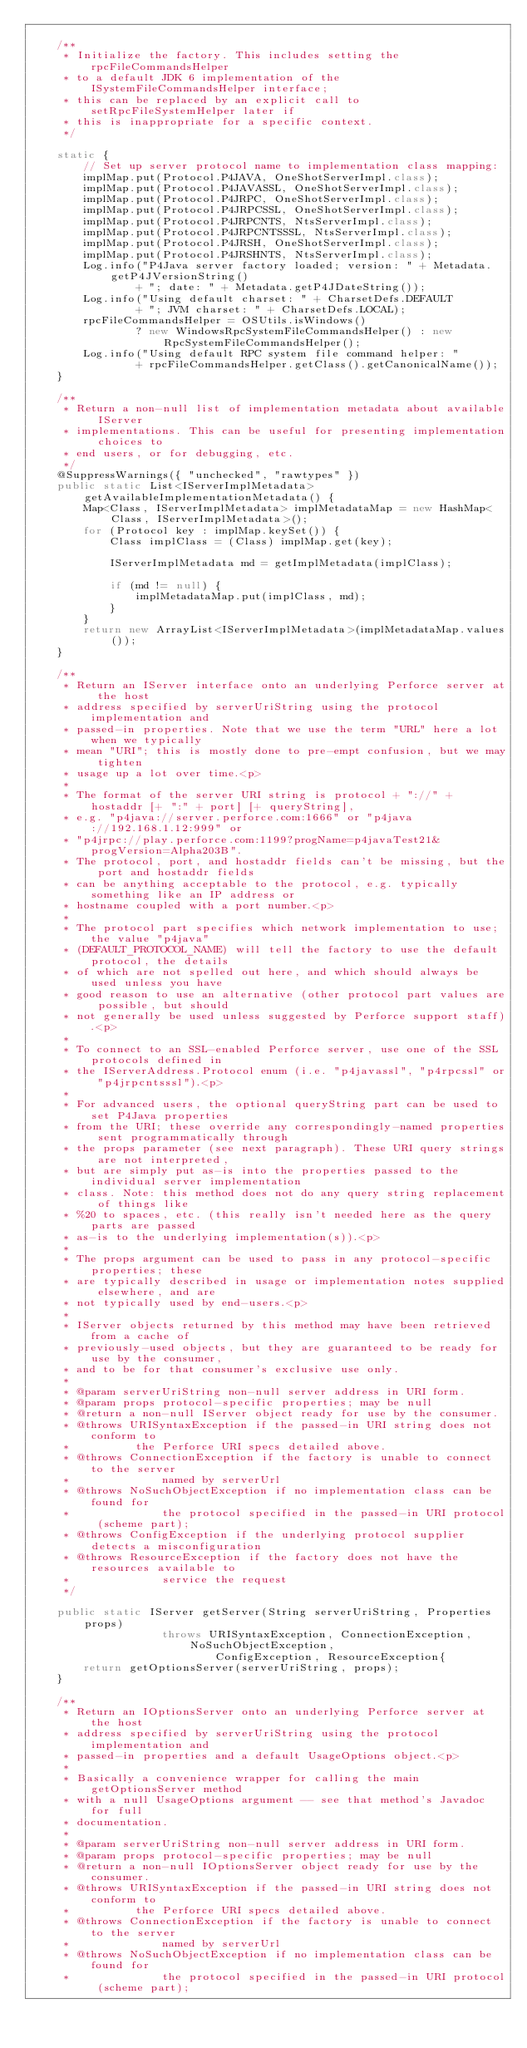<code> <loc_0><loc_0><loc_500><loc_500><_Java_>	
	/**
	 * Initialize the factory. This includes setting the rpcFileCommandsHelper
	 * to a default JDK 6 implementation of the ISystemFileCommandsHelper interface;
	 * this can be replaced by an explicit call to setRpcFileSystemHelper later if
	 * this is inappropriate for a specific context.
	 */
	
	static {
		// Set up server protocol name to implementation class mapping:
		implMap.put(Protocol.P4JAVA, OneShotServerImpl.class);
		implMap.put(Protocol.P4JAVASSL, OneShotServerImpl.class);
		implMap.put(Protocol.P4JRPC, OneShotServerImpl.class);
		implMap.put(Protocol.P4JRPCSSL, OneShotServerImpl.class);
		implMap.put(Protocol.P4JRPCNTS, NtsServerImpl.class);
		implMap.put(Protocol.P4JRPCNTSSSL, NtsServerImpl.class);
		implMap.put(Protocol.P4JRSH, OneShotServerImpl.class);
		implMap.put(Protocol.P4JRSHNTS, NtsServerImpl.class);
		Log.info("P4Java server factory loaded; version: " + Metadata.getP4JVersionString()
				+ "; date: " + Metadata.getP4JDateString());
		Log.info("Using default charset: " + CharsetDefs.DEFAULT
				+ "; JVM charset: " + CharsetDefs.LOCAL);
		rpcFileCommandsHelper = OSUtils.isWindows() 
		        ? new WindowsRpcSystemFileCommandsHelper() : new RpcSystemFileCommandsHelper();
		Log.info("Using default RPC system file command helper: "
				+ rpcFileCommandsHelper.getClass().getCanonicalName());
	}
	
	/**
	 * Return a non-null list of implementation metadata about available IServer
	 * implementations. This can be useful for presenting implementation choices to
	 * end users, or for debugging, etc.
	 */
	@SuppressWarnings({ "unchecked", "rawtypes" })
	public static List<IServerImplMetadata> getAvailableImplementationMetadata() {
		Map<Class, IServerImplMetadata> implMetadataMap = new HashMap<Class, IServerImplMetadata>();
		for (Protocol key : implMap.keySet()) {
			Class implClass = (Class) implMap.get(key);
			
			IServerImplMetadata md = getImplMetadata(implClass);
			
			if (md != null) {
				implMetadataMap.put(implClass, md);
			}
		}
		return new ArrayList<IServerImplMetadata>(implMetadataMap.values());
	}
	
	/**
	 * Return an IServer interface onto an underlying Perforce server at the host
	 * address specified by serverUriString using the protocol implementation and
	 * passed-in properties. Note that we use the term "URL" here a lot when we typically
	 * mean "URI"; this is mostly done to pre-empt confusion, but we may tighten
	 * usage up a lot over time.<p>
	 * 
	 * The format of the server URI string is protocol + "://" + hostaddr [+ ":" + port] [+ queryString],
	 * e.g. "p4java://server.perforce.com:1666" or "p4java://192.168.1.12:999" or
	 * "p4jrpc://play.perforce.com:1199?progName=p4javaTest21&progVersion=Alpha203B".
	 * The protocol, port, and hostaddr fields can't be missing, but the port and hostaddr fields
	 * can be anything acceptable to the protocol, e.g. typically something like an IP address or
	 * hostname coupled with a port number.<p>
	 * 
	 * The protocol part specifies which network implementation to use; the value "p4java"
	 * (DEFAULT_PROTOCOL_NAME) will tell the factory to use the default protocol, the details
	 * of which are not spelled out here, and which should always be used unless you have
	 * good reason to use an alternative (other protocol part values are possible, but should
	 * not generally be used unless suggested by Perforce support staff).<p>
	 * 
	 * To connect to an SSL-enabled Perforce server, use one of the SSL protocols defined in
	 * the IServerAddress.Protocol enum (i.e. "p4javassl", "p4rpcssl" or "p4jrpcntsssl").<p>
	 * 
	 * For advanced users, the optional queryString part can be used to set P4Java properties
	 * from the URI; these override any correspondingly-named properties sent programmatically through
	 * the props parameter (see next paragraph). These URI query strings are not interpreted,
	 * but are simply put as-is into the properties passed to the individual server implementation
	 * class. Note: this method does not do any query string replacement of things like
	 * %20 to spaces, etc. (this really isn't needed here as the query parts are passed
	 * as-is to the underlying implementation(s)).<p>
	 * 
	 * The props argument can be used to pass in any protocol-specific properties; these
	 * are typically described in usage or implementation notes supplied elsewhere, and are
	 * not typically used by end-users.<p>
	 * 
	 * IServer objects returned by this method may have been retrieved from a cache of
	 * previously-used objects, but they are guaranteed to be ready for use by the consumer,
	 * and to be for that consumer's exclusive use only.
	 * 
	 * @param serverUriString non-null server address in URI form.
	 * @param props protocol-specific properties; may be null
	 * @return a non-null IServer object ready for use by the consumer.
	 * @throws URISyntaxException if the passed-in URI string does not conform to
	 * 			the Perforce URI specs detailed above.
	 * @throws ConnectionException if the factory is unable to connect to the server
	 * 				named by serverUrl
	 * @throws NoSuchObjectException if no implementation class can be found for
	 * 				the protocol specified in the passed-in URI protocol (scheme part);
	 * @throws ConfigException if the underlying protocol supplier detects a misconfiguration
	 * @throws ResourceException if the factory does not have the resources available to
	 * 				service the request
	 */
	
	public static IServer getServer(String serverUriString, Properties props)
					throws URISyntaxException, ConnectionException, NoSuchObjectException,
							ConfigException, ResourceException{
		return getOptionsServer(serverUriString, props);
	}
	
	/**
	 * Return an IOptionsServer onto an underlying Perforce server at the host
	 * address specified by serverUriString using the protocol implementation and
	 * passed-in properties and a default UsageOptions object.<p>
	 * 
	 * Basically a convenience wrapper for calling the main getOptionsServer method
	 * with a null UsageOptions argument -- see that method's Javadoc for full
	 * documentation.
	 * 
	 * @param serverUriString non-null server address in URI form.
	 * @param props protocol-specific properties; may be null
	 * @return a non-null IOptionsServer object ready for use by the consumer.
	 * @throws URISyntaxException if the passed-in URI string does not conform to
	 * 			the Perforce URI specs detailed above.
	 * @throws ConnectionException if the factory is unable to connect to the server
	 * 				named by serverUrl
	 * @throws NoSuchObjectException if no implementation class can be found for
	 * 				the protocol specified in the passed-in URI protocol (scheme part);</code> 